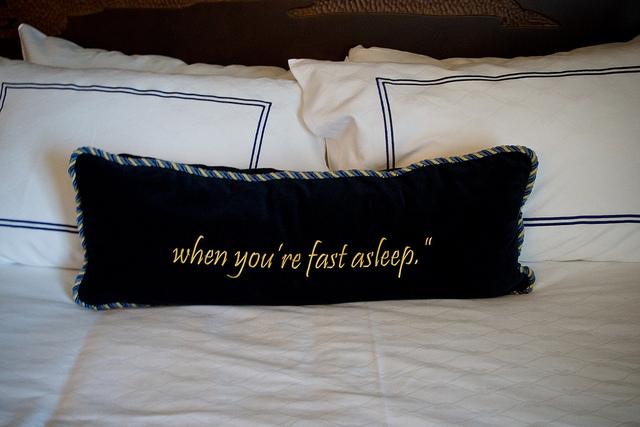Is the grammar on the pillow correct?
Be succinct. Yes. Is this a hotel bed?
Keep it brief. Yes. What color is the lettering on the pillow?
Short answer required. Yellow. 